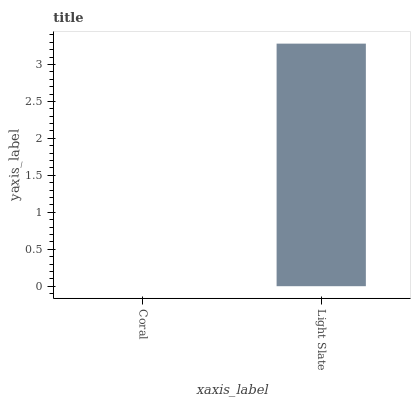Is Coral the minimum?
Answer yes or no. Yes. Is Light Slate the maximum?
Answer yes or no. Yes. Is Light Slate the minimum?
Answer yes or no. No. Is Light Slate greater than Coral?
Answer yes or no. Yes. Is Coral less than Light Slate?
Answer yes or no. Yes. Is Coral greater than Light Slate?
Answer yes or no. No. Is Light Slate less than Coral?
Answer yes or no. No. Is Light Slate the high median?
Answer yes or no. Yes. Is Coral the low median?
Answer yes or no. Yes. Is Coral the high median?
Answer yes or no. No. Is Light Slate the low median?
Answer yes or no. No. 